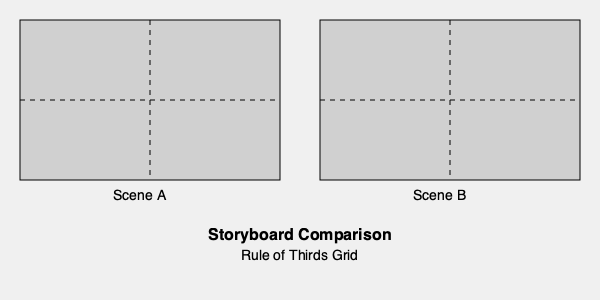Analyze the visual composition of Scene A and Scene B using the provided storyboard comparison. How does the application of the Rule of Thirds differ between these two scenes, and what impact might this have on the audience's perception of each location? To answer this question, we need to examine the storyboard comparison and analyze the application of the Rule of Thirds in each scene:

1. Rule of Thirds: This compositional guideline divides the frame into a 3x3 grid, with important elements placed along the lines or at their intersections.

2. Scene A analysis:
   - The main subject appears to be centered in the frame.
   - No significant elements are placed along the third lines or at their intersections.
   - This composition creates a sense of stability and directness.

3. Scene B analysis:
   - The main subject or focus seems to be placed off-center, likely near one of the intersection points of the thirds grid.
   - This composition creates a more dynamic and visually interesting frame.

4. Impact on audience perception:
   - Scene A's centered composition may make the location feel more formal, static, or imposing.
   - Scene B's off-center composition could make the location feel more natural, dynamic, or engaging.

5. Location impact:
   - Scene A's composition might be used for establishing shots of grand locations or to emphasize symmetry in architecture.
   - Scene B's composition could be used to showcase the relationship between characters and their environment or to guide the viewer's eye through the location.

The different applications of the Rule of Thirds in these scenes would likely result in distinct emotional responses and interpretations of the film locations by the audience.
Answer: Scene A uses centered composition for stability, while Scene B applies the Rule of Thirds for dynamism, impacting the audience's perception of each location's formality and engagement. 